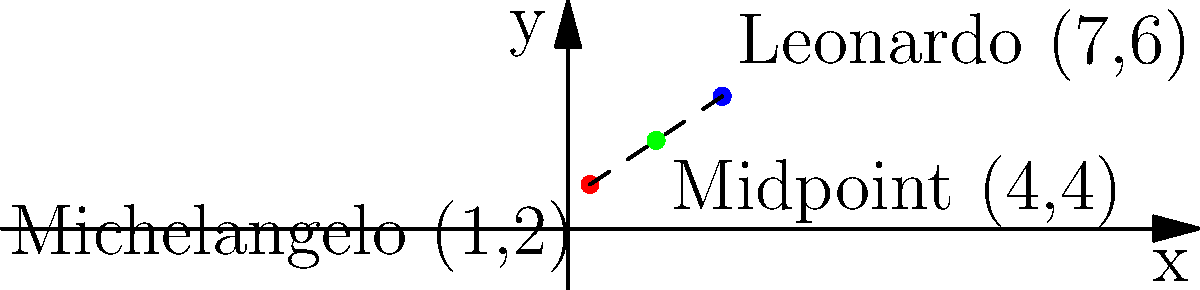On a coordinate map of Renaissance Italy, Michelangelo's birthplace is located at (1,2) and Leonardo da Vinci's birthplace is at (7,6). What are the coordinates of the midpoint between these two locations? Express your answer as an ordered pair $(x,y)$. To find the midpoint between two points, we use the midpoint formula:

$(\frac{x_1 + x_2}{2}, \frac{y_1 + y_2}{2})$

Where $(x_1, y_1)$ is the first point and $(x_2, y_2)$ is the second point.

1. Identify the coordinates:
   Michelangelo: $(x_1, y_1) = (1, 2)$
   Leonardo: $(x_2, y_2) = (7, 6)$

2. Calculate the x-coordinate of the midpoint:
   $x = \frac{x_1 + x_2}{2} = \frac{1 + 7}{2} = \frac{8}{2} = 4$

3. Calculate the y-coordinate of the midpoint:
   $y = \frac{y_1 + y_2}{2} = \frac{2 + 6}{2} = \frac{8}{2} = 4$

4. Combine the results into an ordered pair:
   Midpoint = $(4, 4)$

This point represents the location exactly halfway between Michelangelo's and Leonardo's birthplaces on the coordinate map.
Answer: $(4,4)$ 